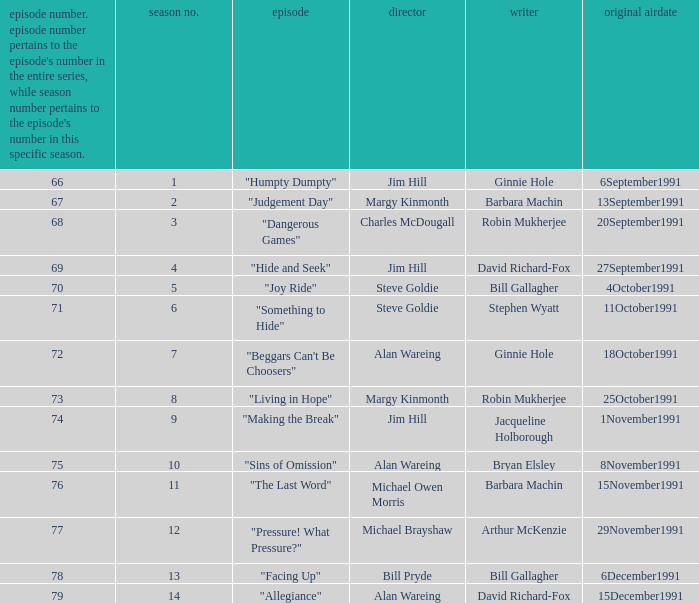Name the original airdate for robin mukherjee and margy kinmonth 25October1991. 